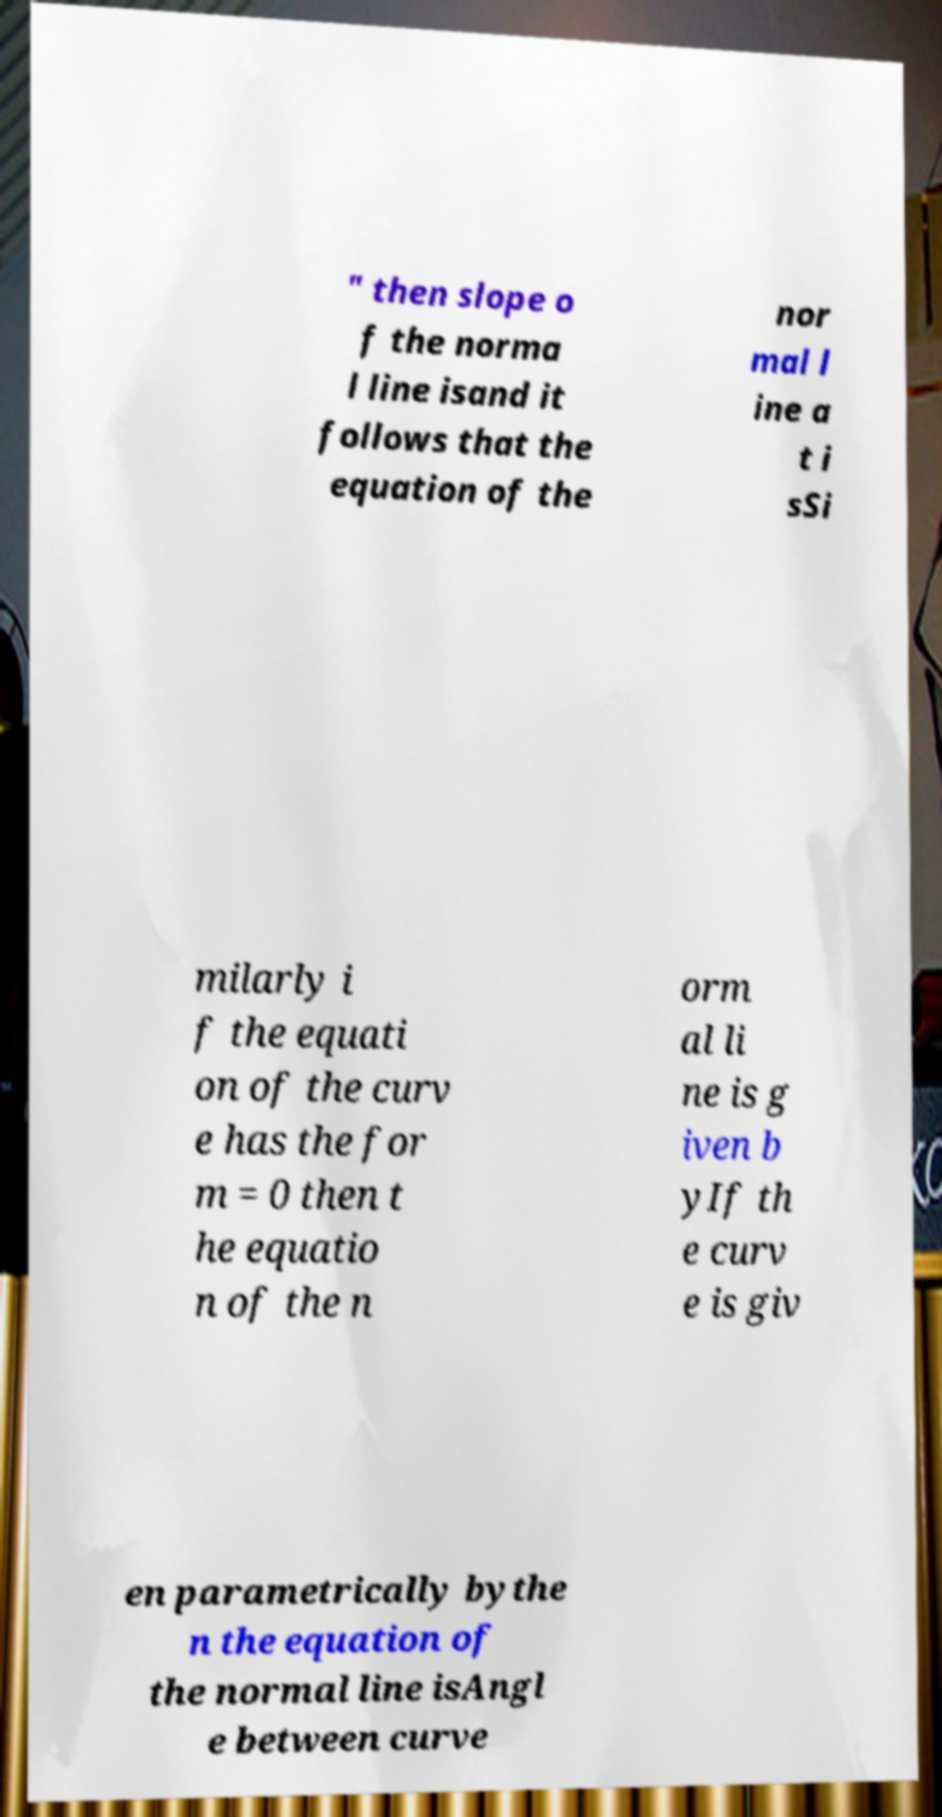Can you explain what a normal line to a curve is and how it's calculated? A normal line to a curve at a given point is the line perpendicular to the tangent line at that point. Typically, if you know the derivative of the curve at that point, the slope of the tangent line is the value of this derivative. The normal line's slope is the negative reciprocal of the tangent's slope. If the equation of the curve is given in a standard form y=f(x), and the derivative at the point in question is m, then the slope of the normal line would be -1/m. 